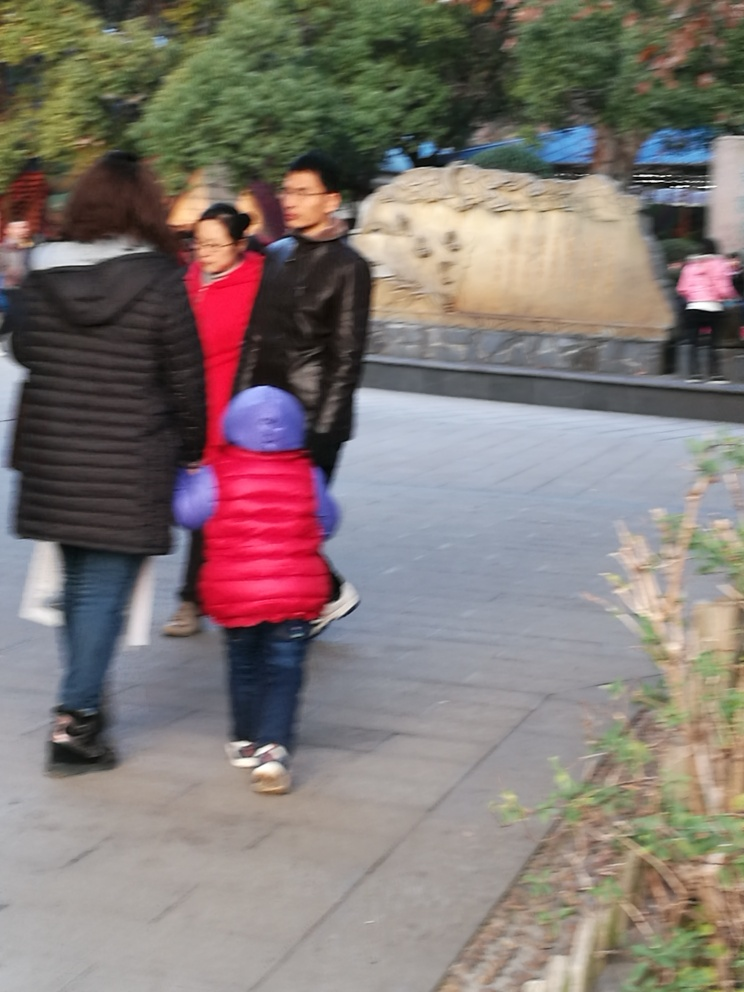Is there anything in the background that might indicate where this image was taken? In the background, there appears to be a large carved stone object which might be a clue to the cultural or historical significance of the location. This type of sculpture often implies that the image could have been taken at a site of historical interest, possibly a park, museum, or a place with historical markers. 